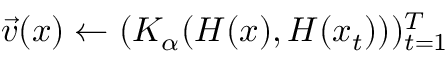<formula> <loc_0><loc_0><loc_500><loc_500>\vec { v } ( x ) \gets ( K _ { \alpha } ( H ( x ) , H ( x _ { t } ) ) ) _ { t = 1 } ^ { T }</formula> 